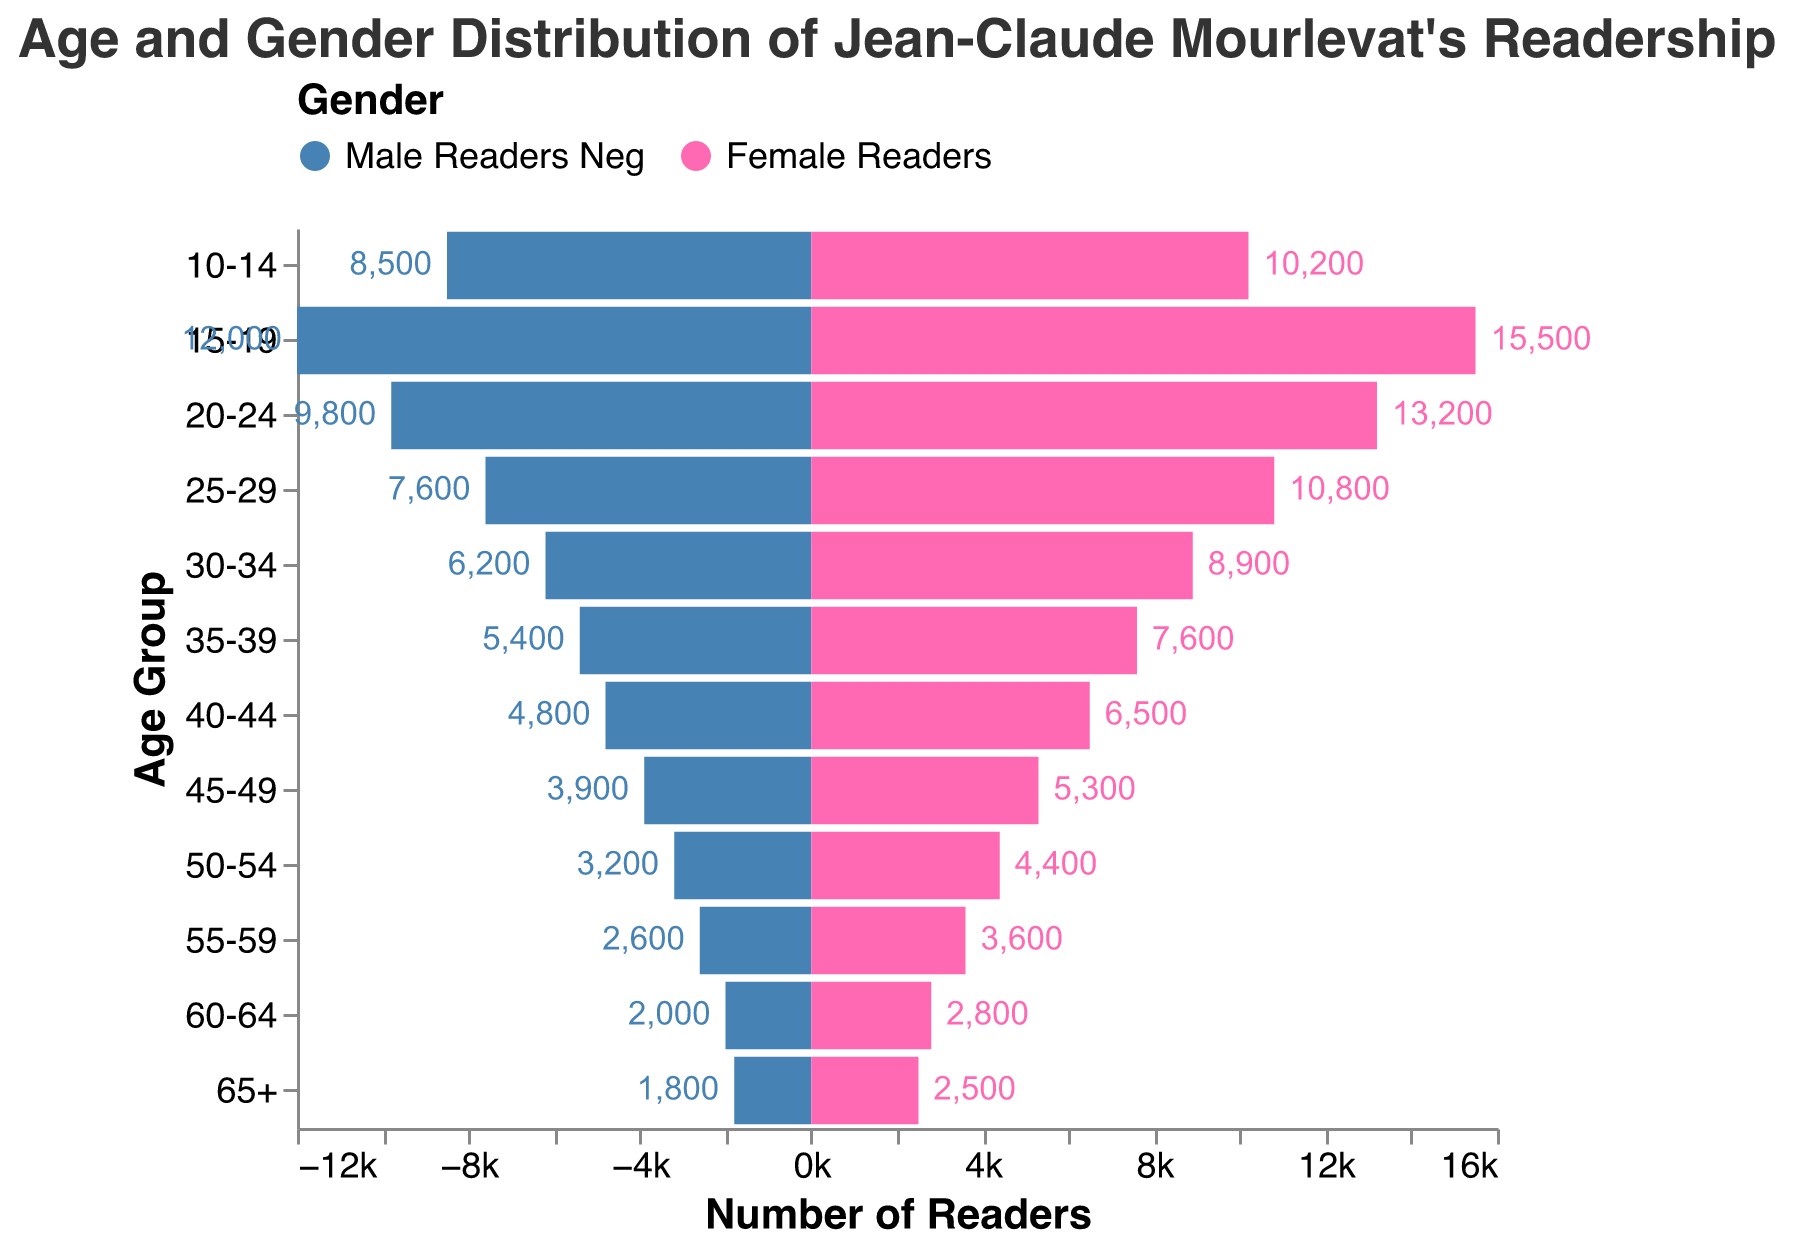What's the title of the plot? The title of the plot is prominently displayed at the top and reads: "Age and Gender Distribution of Jean-Claude Mourlevat's Readership."
Answer: Age and Gender Distribution of Jean-Claude Mourlevat's Readership What's the range of readers in the 10-14 age group? The plot shows 8,500 male readers and 10,200 female readers in the 10-14 age group.
Answer: 8,500 to 10,200 Which age group has the highest number of female readers? By looking at the lengths of the bars on the female side, the age group 15-19 has the highest number of female readers with 15,500 readers.
Answer: 15-19 What is the total number of readers in the 20-24 age group? Adding the number of male readers (9,800) and female readers (13,200) in the 20-24 age group gives 9,800 + 13,200 = 23,000 total readers.
Answer: 23,000 How many more female readers than male readers are there in the 25-29 age group? There are 10,800 female readers and 7,600 male readers. The difference is 10,800 - 7,600 = 3,200 more female readers.
Answer: 3,200 What age group has the fewest male readers? By looking at the lengths of the bars on the male side, the 65+ age group has the fewest male readers with 1,800 readers.
Answer: 65+ Compare the number of readers between the 15-19 and 55-59 age groups for both genders. Who has more readers? In the 15-19 age group, males have 12,000 readers and females have 15,500 readers. In the 55-59 age group, males have 2,600 readers and females have 3,600 readers. Clearly, the 15-19 age group has more readers for both genders (12,000 and 15,500) compared to the 55-59 age group (2,600 and 3,600).
Answer: 15-19 Which gender generally has more readers across most age groups? Observing the pattern in the plot, the female bars are longer than the male bars for most age groups, indicating that females generally have more readers.
Answer: Female What is the combined total of readers in the 60-64 age group? Adding the male readers (2,000) and female readers (2,800) in the 60-64 age group results in 2,000 + 2,800 = 4,800 total readers.
Answer: 4,800 